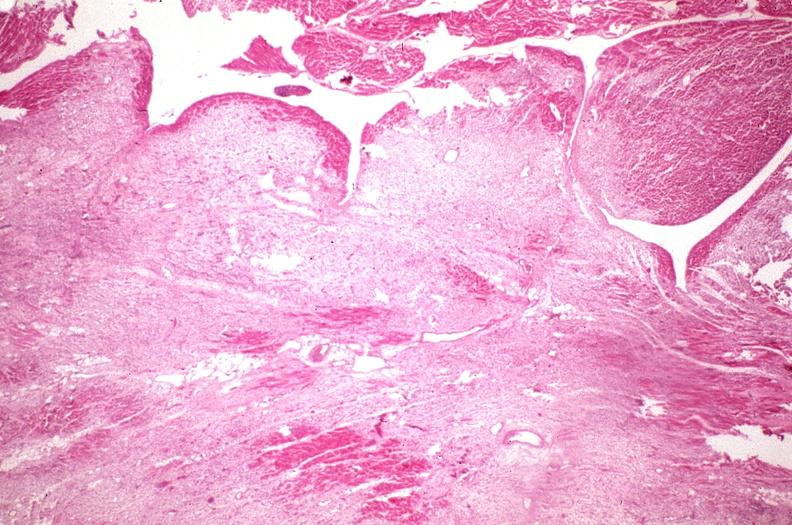does all the fat necrosis show heart, fibrosis, chronic rheumatic heart disease?
Answer the question using a single word or phrase. No 